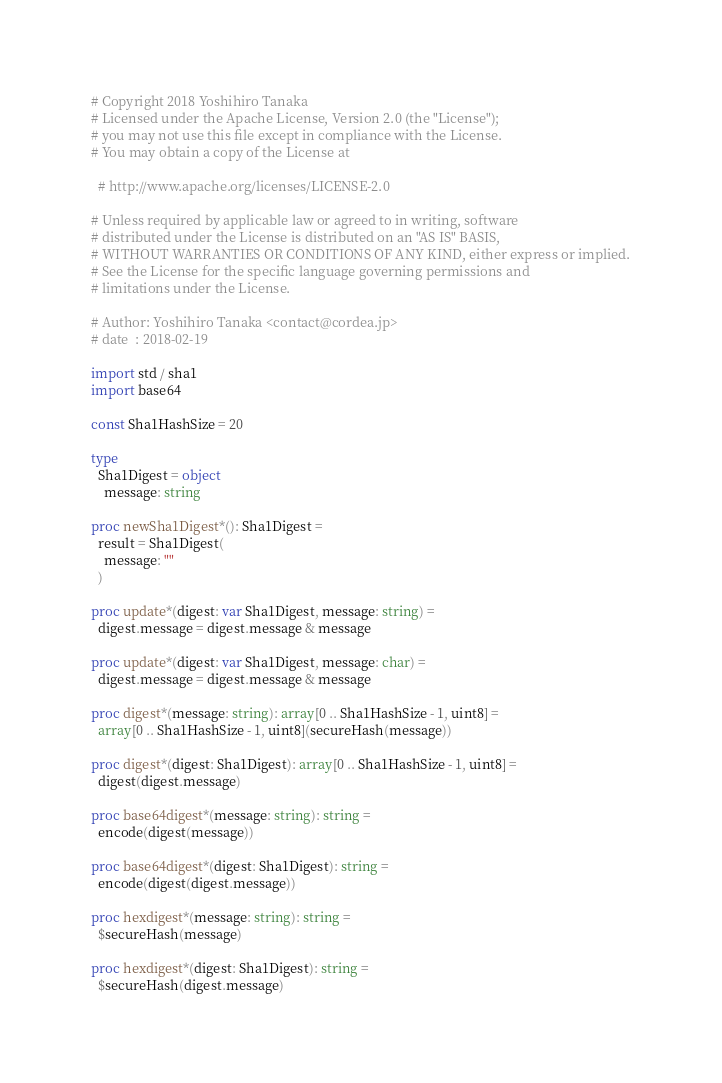Convert code to text. <code><loc_0><loc_0><loc_500><loc_500><_Nim_># Copyright 2018 Yoshihiro Tanaka
# Licensed under the Apache License, Version 2.0 (the "License");
# you may not use this file except in compliance with the License.
# You may obtain a copy of the License at

  # http://www.apache.org/licenses/LICENSE-2.0

# Unless required by applicable law or agreed to in writing, software
# distributed under the License is distributed on an "AS IS" BASIS,
# WITHOUT WARRANTIES OR CONDITIONS OF ANY KIND, either express or implied.
# See the License for the specific language governing permissions and
# limitations under the License.

# Author: Yoshihiro Tanaka <contact@cordea.jp>
# date  : 2018-02-19

import std / sha1
import base64

const Sha1HashSize = 20

type
  Sha1Digest = object
    message: string

proc newSha1Digest*(): Sha1Digest =
  result = Sha1Digest(
    message: ""
  )

proc update*(digest: var Sha1Digest, message: string) =
  digest.message = digest.message & message

proc update*(digest: var Sha1Digest, message: char) =
  digest.message = digest.message & message

proc digest*(message: string): array[0 .. Sha1HashSize - 1, uint8] =
  array[0 .. Sha1HashSize - 1, uint8](secureHash(message))

proc digest*(digest: Sha1Digest): array[0 .. Sha1HashSize - 1, uint8] =
  digest(digest.message)

proc base64digest*(message: string): string =
  encode(digest(message))

proc base64digest*(digest: Sha1Digest): string =
  encode(digest(digest.message))

proc hexdigest*(message: string): string =
  $secureHash(message)

proc hexdigest*(digest: Sha1Digest): string =
  $secureHash(digest.message)
</code> 